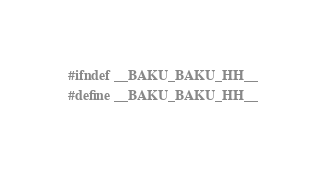Convert code to text. <code><loc_0><loc_0><loc_500><loc_500><_C++_>#ifndef __BAKU_BAKU_HH__
#define __BAKU_BAKU_HH__
</code> 